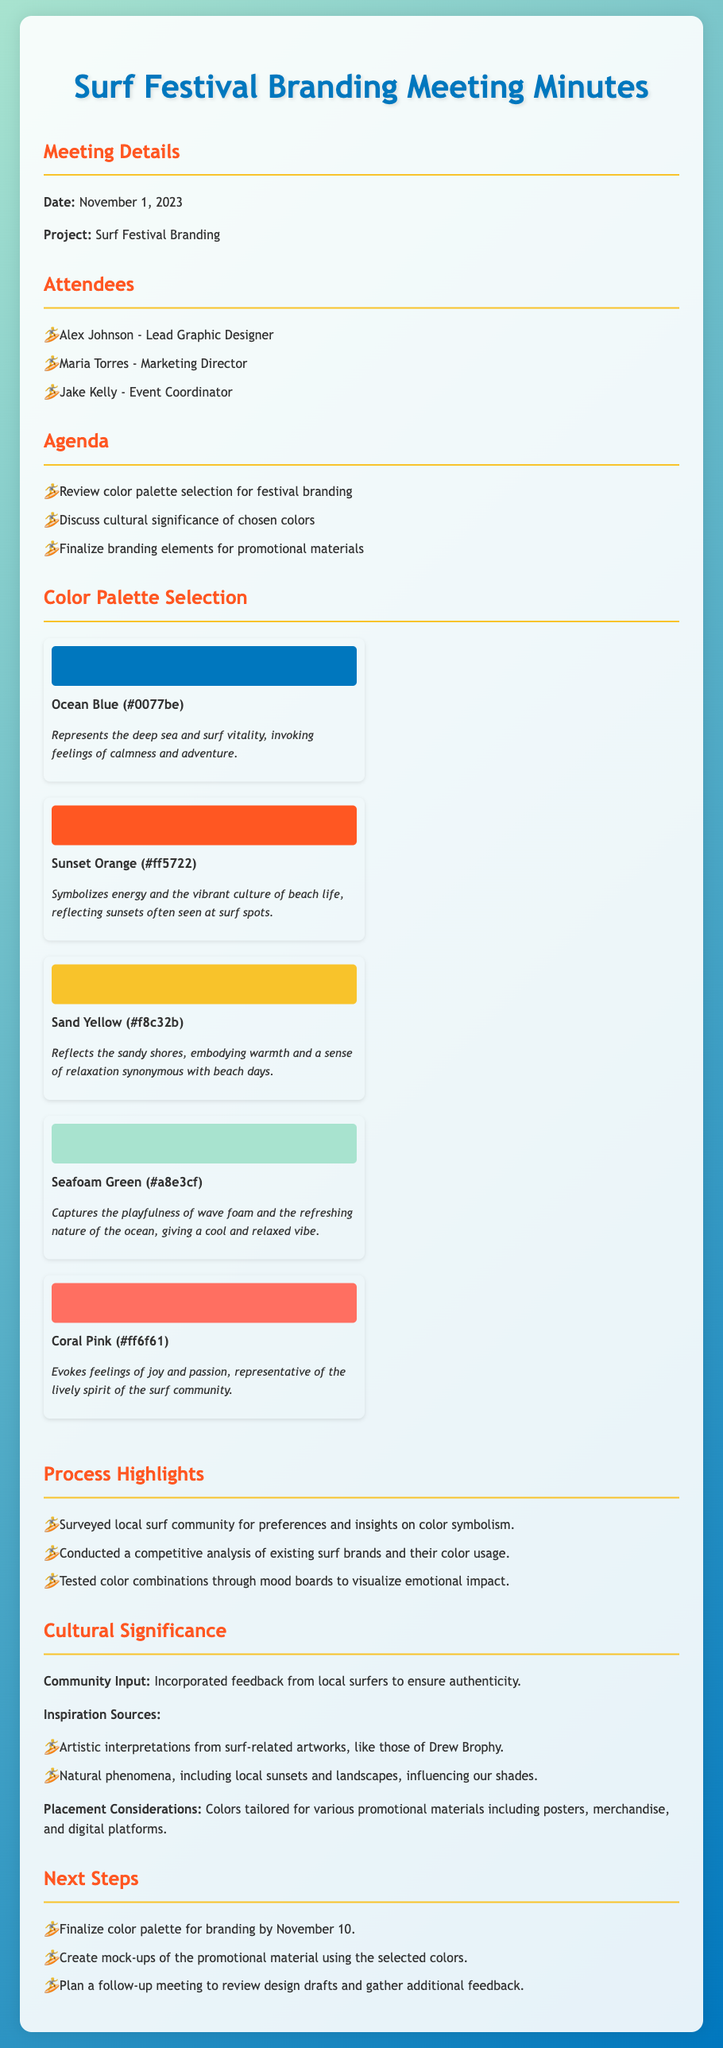What is the date of the meeting? The date of the meeting is mentioned in the document as November 1, 2023.
Answer: November 1, 2023 Who is the Lead Graphic Designer? The document lists Alex Johnson as the Lead Graphic Designer.
Answer: Alex Johnson What shade represents the deep sea? The document specifies Ocean Blue as the shade that represents the deep sea.
Answer: Ocean Blue How many colors are in the selected palette? The document lists a total of five colors for the festival branding.
Answer: Five What color symbolizes energy? Sunset Orange is stated as the color that symbolizes energy in the document.
Answer: Sunset Orange Which color reflects the sandy shores? Sand Yellow is identified in the document as the color reflecting the sandy shores.
Answer: Sand Yellow What was incorporated to ensure authenticity? Community input from local surfers was incorporated, as mentioned in the Cultural Significance section.
Answer: Community input What is the deadline to finalize the color palette? The document states that the deadline to finalize the color palette is November 10.
Answer: November 10 What type of analysis was conducted for color usage? A competitive analysis of existing surf brands was conducted, as noted in the process highlights.
Answer: Competitive analysis 